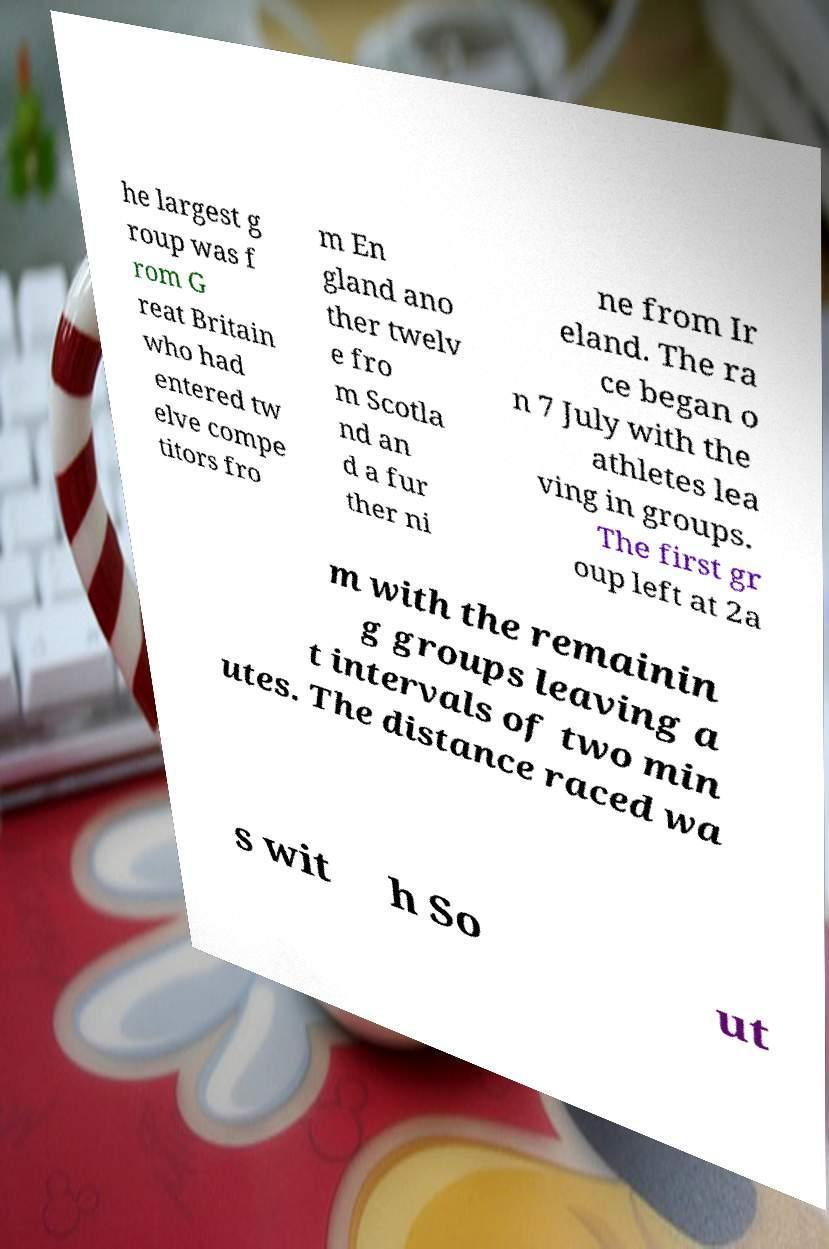I need the written content from this picture converted into text. Can you do that? he largest g roup was f rom G reat Britain who had entered tw elve compe titors fro m En gland ano ther twelv e fro m Scotla nd an d a fur ther ni ne from Ir eland. The ra ce began o n 7 July with the athletes lea ving in groups. The first gr oup left at 2a m with the remainin g groups leaving a t intervals of two min utes. The distance raced wa s wit h So ut 